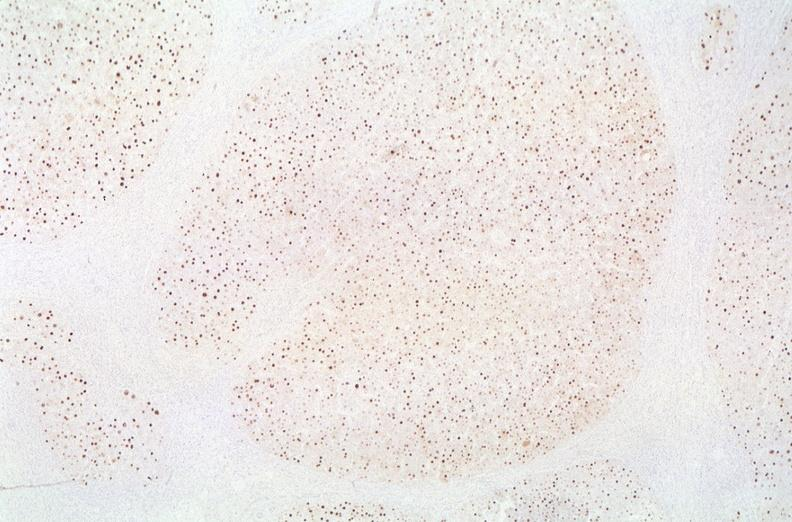s liver present?
Answer the question using a single word or phrase. Yes 